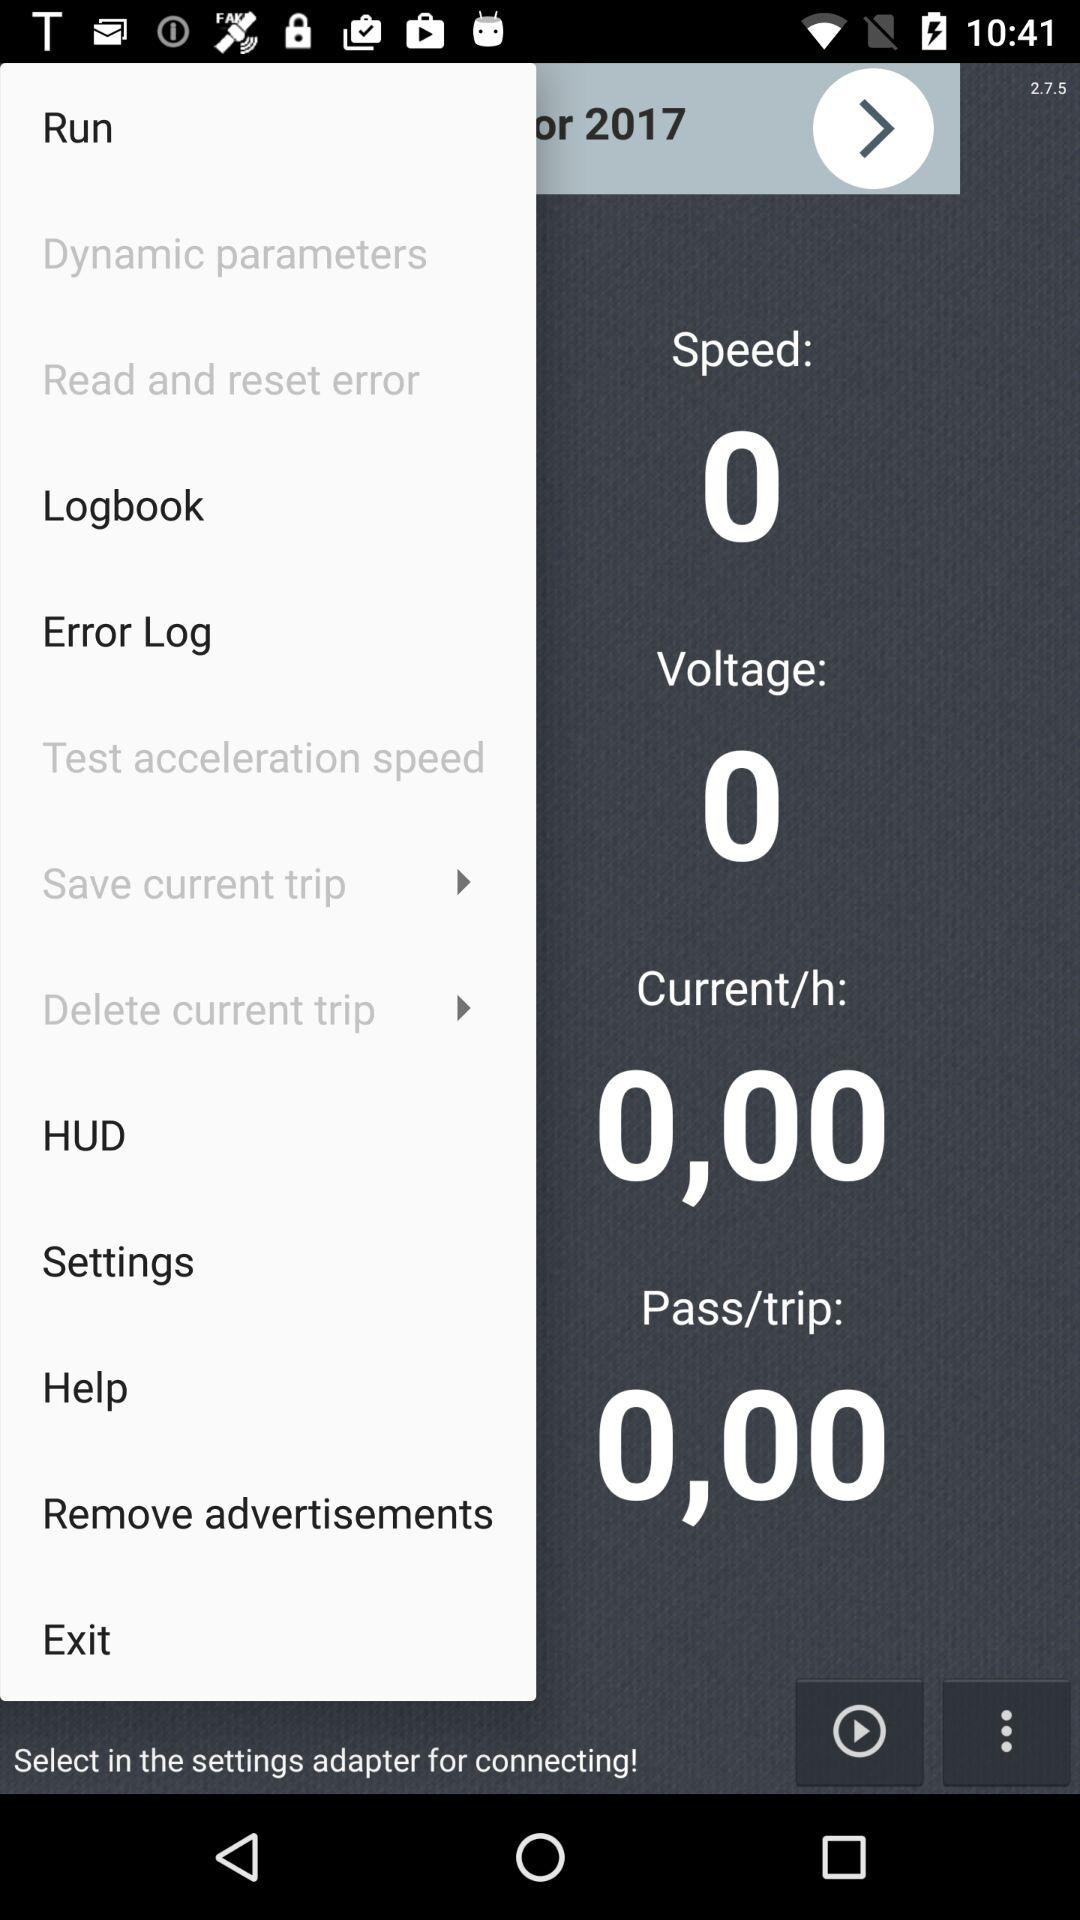What is the speed? The speed is 0. 